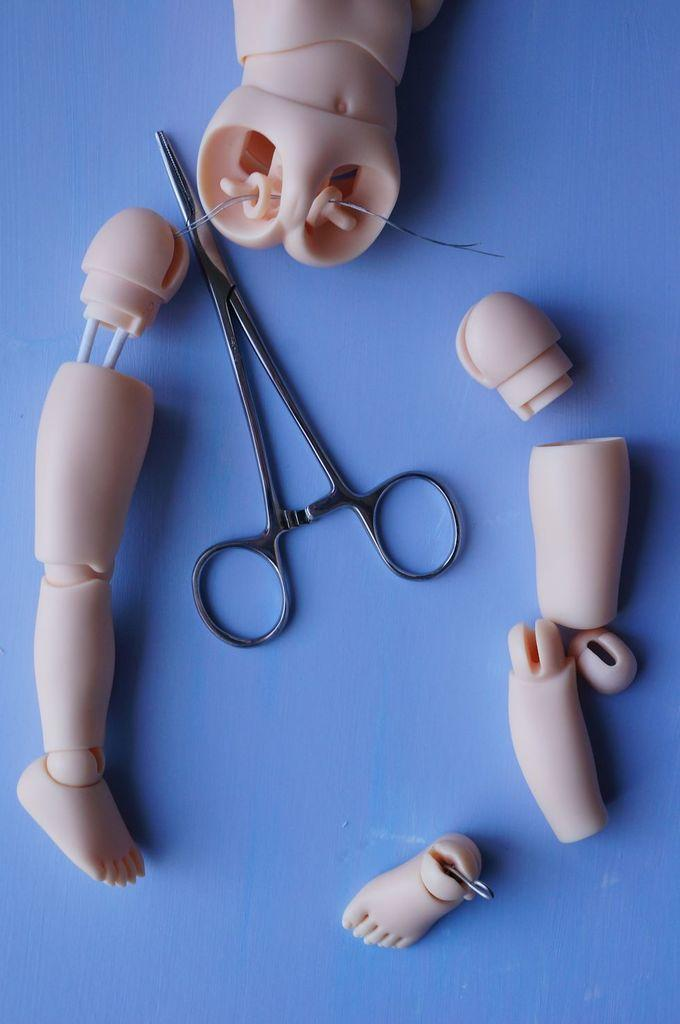What is the main object in the image? There is a table in the image. What can be found on the table? There is a scissor and different parts of a toy on the table. What type of milk is being poured from the scissor in the image? There is no milk present in the image; it only features a scissor and different parts of a toy on the table. 